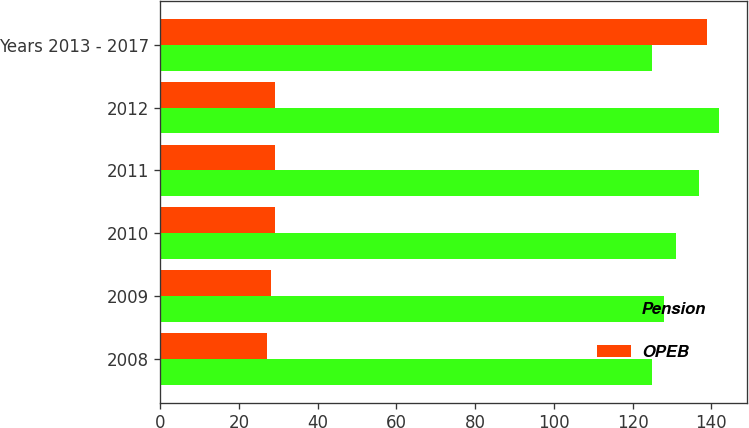Convert chart to OTSL. <chart><loc_0><loc_0><loc_500><loc_500><stacked_bar_chart><ecel><fcel>2008<fcel>2009<fcel>2010<fcel>2011<fcel>2012<fcel>Years 2013 - 2017<nl><fcel>Pension<fcel>125<fcel>128<fcel>131<fcel>137<fcel>142<fcel>125<nl><fcel>OPEB<fcel>27<fcel>28<fcel>29<fcel>29<fcel>29<fcel>139<nl></chart> 